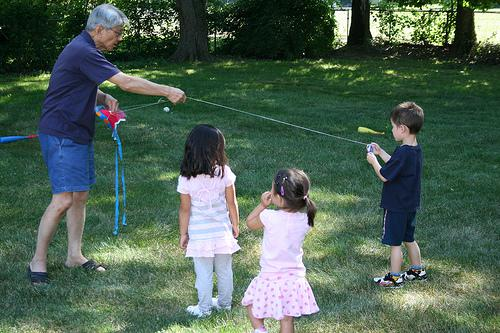Question: who is in the picture?
Choices:
A. Actors.
B. School children.
C. Two males and two females.
D. Bride and groom.
Answer with the letter. Answer: C Question: how many people are in the picture?
Choices:
A. 5.
B. 4.
C. 6.
D. 7.
Answer with the letter. Answer: B Question: what color is the little boys shirt?
Choices:
A. Blue.
B. Yellow.
C. Red.
D. Orange.
Answer with the letter. Answer: A Question: why are there shadows on the ground?
Choices:
A. The street light is on.
B. The moon is lighting up the night.
C. The fire is casting shadows.
D. The sun is shining through the trees.
Answer with the letter. Answer: D Question: what color is the man's hair?
Choices:
A. Grey.
B. Black.
C. Brown.
D. Blonde.
Answer with the letter. Answer: A Question: what kind of pants is the man wearing?
Choices:
A. Khakis.
B. Sweat pants.
C. Suit pants.
D. Blue jeans.
Answer with the letter. Answer: D Question: where was the picture taken?
Choices:
A. On a mountain.
B. At a farm.
C. At the zoo.
D. In a park.
Answer with the letter. Answer: D 